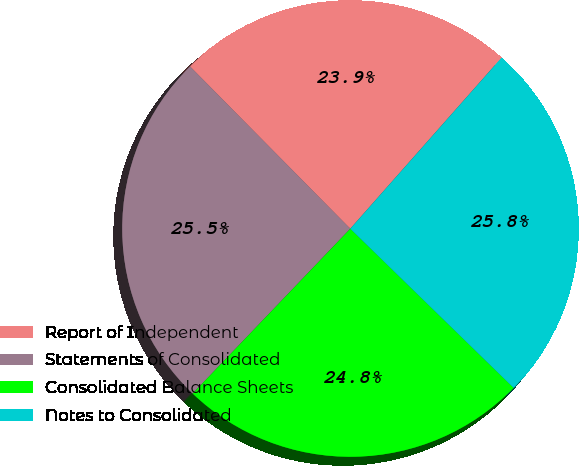Convert chart. <chart><loc_0><loc_0><loc_500><loc_500><pie_chart><fcel>Report of Independent<fcel>Statements of Consolidated<fcel>Consolidated Balance Sheets<fcel>Notes to Consolidated<nl><fcel>23.93%<fcel>25.46%<fcel>24.85%<fcel>25.77%<nl></chart> 